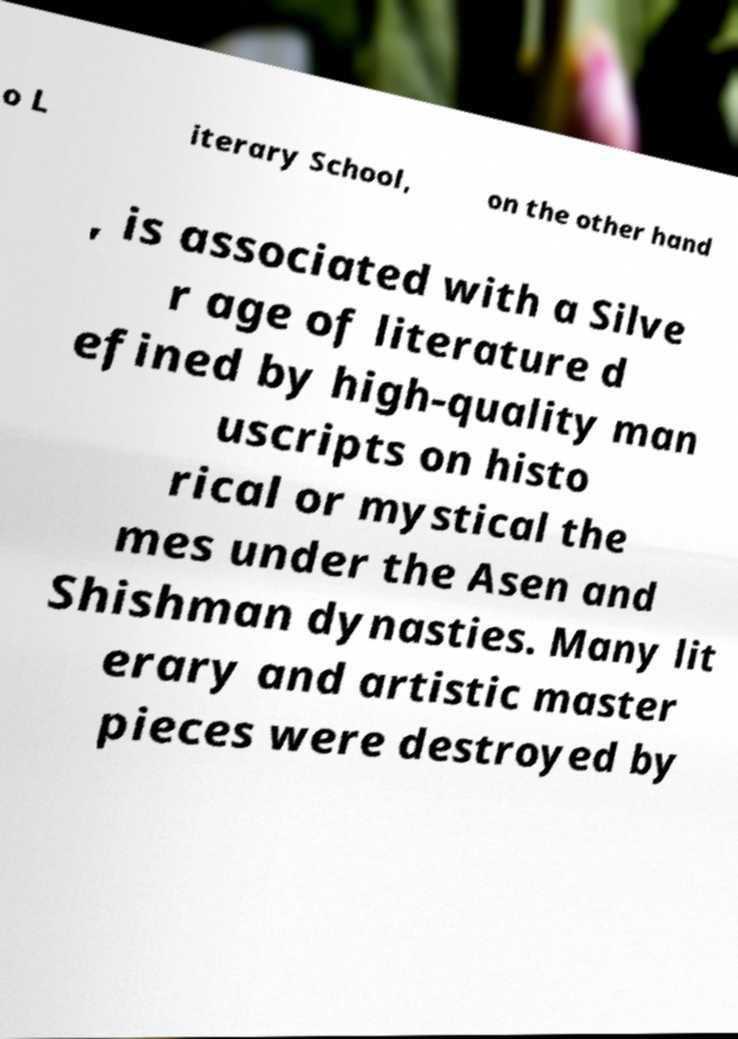Could you assist in decoding the text presented in this image and type it out clearly? o L iterary School, on the other hand , is associated with a Silve r age of literature d efined by high-quality man uscripts on histo rical or mystical the mes under the Asen and Shishman dynasties. Many lit erary and artistic master pieces were destroyed by 